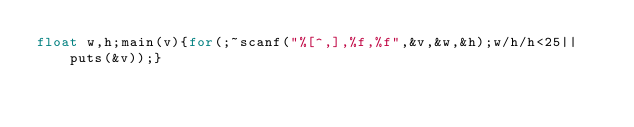<code> <loc_0><loc_0><loc_500><loc_500><_C_>float w,h;main(v){for(;~scanf("%[^,],%f,%f",&v,&w,&h);w/h/h<25||puts(&v));}</code> 